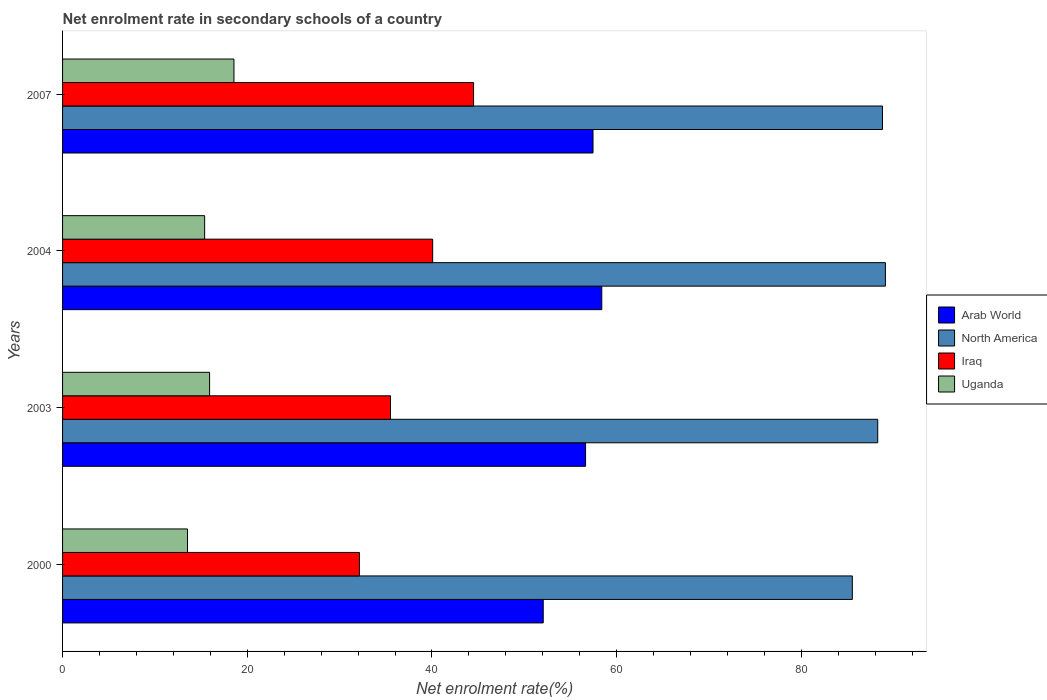Are the number of bars per tick equal to the number of legend labels?
Give a very brief answer. Yes. How many bars are there on the 1st tick from the bottom?
Your response must be concise. 4. In how many cases, is the number of bars for a given year not equal to the number of legend labels?
Ensure brevity in your answer.  0. What is the net enrolment rate in secondary schools in Iraq in 2004?
Give a very brief answer. 40.07. Across all years, what is the maximum net enrolment rate in secondary schools in Iraq?
Provide a short and direct response. 44.5. Across all years, what is the minimum net enrolment rate in secondary schools in Iraq?
Give a very brief answer. 32.14. In which year was the net enrolment rate in secondary schools in Iraq maximum?
Your answer should be compact. 2007. In which year was the net enrolment rate in secondary schools in Iraq minimum?
Make the answer very short. 2000. What is the total net enrolment rate in secondary schools in Arab World in the graph?
Offer a terse response. 224.5. What is the difference between the net enrolment rate in secondary schools in Iraq in 2000 and that in 2007?
Give a very brief answer. -12.36. What is the difference between the net enrolment rate in secondary schools in Arab World in 2000 and the net enrolment rate in secondary schools in North America in 2007?
Give a very brief answer. -36.73. What is the average net enrolment rate in secondary schools in North America per year?
Offer a very short reply. 87.92. In the year 2007, what is the difference between the net enrolment rate in secondary schools in Iraq and net enrolment rate in secondary schools in Uganda?
Make the answer very short. 25.94. In how many years, is the net enrolment rate in secondary schools in Iraq greater than 68 %?
Keep it short and to the point. 0. What is the ratio of the net enrolment rate in secondary schools in North America in 2000 to that in 2004?
Make the answer very short. 0.96. Is the net enrolment rate in secondary schools in Uganda in 2003 less than that in 2007?
Your answer should be compact. Yes. Is the difference between the net enrolment rate in secondary schools in Iraq in 2003 and 2004 greater than the difference between the net enrolment rate in secondary schools in Uganda in 2003 and 2004?
Make the answer very short. No. What is the difference between the highest and the second highest net enrolment rate in secondary schools in Arab World?
Keep it short and to the point. 0.95. What is the difference between the highest and the lowest net enrolment rate in secondary schools in North America?
Your response must be concise. 3.58. In how many years, is the net enrolment rate in secondary schools in North America greater than the average net enrolment rate in secondary schools in North America taken over all years?
Your answer should be compact. 3. Is the sum of the net enrolment rate in secondary schools in Arab World in 2000 and 2007 greater than the maximum net enrolment rate in secondary schools in North America across all years?
Your response must be concise. Yes. Is it the case that in every year, the sum of the net enrolment rate in secondary schools in Arab World and net enrolment rate in secondary schools in North America is greater than the sum of net enrolment rate in secondary schools in Uganda and net enrolment rate in secondary schools in Iraq?
Give a very brief answer. Yes. What does the 2nd bar from the top in 2007 represents?
Offer a very short reply. Iraq. How many bars are there?
Your response must be concise. 16. What is the difference between two consecutive major ticks on the X-axis?
Offer a very short reply. 20. Are the values on the major ticks of X-axis written in scientific E-notation?
Make the answer very short. No. Does the graph contain grids?
Provide a succinct answer. No. Where does the legend appear in the graph?
Offer a terse response. Center right. How many legend labels are there?
Make the answer very short. 4. How are the legend labels stacked?
Your response must be concise. Vertical. What is the title of the graph?
Keep it short and to the point. Net enrolment rate in secondary schools of a country. What is the label or title of the X-axis?
Give a very brief answer. Net enrolment rate(%). What is the label or title of the Y-axis?
Provide a succinct answer. Years. What is the Net enrolment rate(%) in Arab World in 2000?
Offer a terse response. 52.05. What is the Net enrolment rate(%) in North America in 2000?
Ensure brevity in your answer.  85.52. What is the Net enrolment rate(%) of Iraq in 2000?
Your answer should be compact. 32.14. What is the Net enrolment rate(%) in Uganda in 2000?
Provide a short and direct response. 13.53. What is the Net enrolment rate(%) in Arab World in 2003?
Offer a terse response. 56.63. What is the Net enrolment rate(%) in North America in 2003?
Provide a succinct answer. 88.27. What is the Net enrolment rate(%) in Iraq in 2003?
Your response must be concise. 35.51. What is the Net enrolment rate(%) of Uganda in 2003?
Provide a short and direct response. 15.92. What is the Net enrolment rate(%) in Arab World in 2004?
Keep it short and to the point. 58.39. What is the Net enrolment rate(%) in North America in 2004?
Your answer should be very brief. 89.1. What is the Net enrolment rate(%) of Iraq in 2004?
Your response must be concise. 40.07. What is the Net enrolment rate(%) of Uganda in 2004?
Make the answer very short. 15.38. What is the Net enrolment rate(%) in Arab World in 2007?
Provide a succinct answer. 57.44. What is the Net enrolment rate(%) of North America in 2007?
Provide a succinct answer. 88.78. What is the Net enrolment rate(%) in Iraq in 2007?
Give a very brief answer. 44.5. What is the Net enrolment rate(%) of Uganda in 2007?
Your response must be concise. 18.56. Across all years, what is the maximum Net enrolment rate(%) in Arab World?
Offer a very short reply. 58.39. Across all years, what is the maximum Net enrolment rate(%) of North America?
Offer a terse response. 89.1. Across all years, what is the maximum Net enrolment rate(%) in Iraq?
Keep it short and to the point. 44.5. Across all years, what is the maximum Net enrolment rate(%) of Uganda?
Make the answer very short. 18.56. Across all years, what is the minimum Net enrolment rate(%) in Arab World?
Your answer should be compact. 52.05. Across all years, what is the minimum Net enrolment rate(%) in North America?
Provide a short and direct response. 85.52. Across all years, what is the minimum Net enrolment rate(%) of Iraq?
Provide a succinct answer. 32.14. Across all years, what is the minimum Net enrolment rate(%) in Uganda?
Provide a succinct answer. 13.53. What is the total Net enrolment rate(%) of Arab World in the graph?
Your answer should be compact. 224.5. What is the total Net enrolment rate(%) of North America in the graph?
Your response must be concise. 351.67. What is the total Net enrolment rate(%) of Iraq in the graph?
Your response must be concise. 152.23. What is the total Net enrolment rate(%) in Uganda in the graph?
Your answer should be very brief. 63.39. What is the difference between the Net enrolment rate(%) in Arab World in 2000 and that in 2003?
Provide a short and direct response. -4.58. What is the difference between the Net enrolment rate(%) of North America in 2000 and that in 2003?
Offer a very short reply. -2.75. What is the difference between the Net enrolment rate(%) of Iraq in 2000 and that in 2003?
Ensure brevity in your answer.  -3.37. What is the difference between the Net enrolment rate(%) in Uganda in 2000 and that in 2003?
Offer a terse response. -2.39. What is the difference between the Net enrolment rate(%) of Arab World in 2000 and that in 2004?
Make the answer very short. -6.34. What is the difference between the Net enrolment rate(%) in North America in 2000 and that in 2004?
Your answer should be compact. -3.58. What is the difference between the Net enrolment rate(%) in Iraq in 2000 and that in 2004?
Offer a terse response. -7.93. What is the difference between the Net enrolment rate(%) of Uganda in 2000 and that in 2004?
Provide a short and direct response. -1.85. What is the difference between the Net enrolment rate(%) in Arab World in 2000 and that in 2007?
Provide a succinct answer. -5.39. What is the difference between the Net enrolment rate(%) of North America in 2000 and that in 2007?
Offer a terse response. -3.27. What is the difference between the Net enrolment rate(%) of Iraq in 2000 and that in 2007?
Provide a succinct answer. -12.36. What is the difference between the Net enrolment rate(%) of Uganda in 2000 and that in 2007?
Offer a terse response. -5.03. What is the difference between the Net enrolment rate(%) in Arab World in 2003 and that in 2004?
Your answer should be compact. -1.76. What is the difference between the Net enrolment rate(%) of North America in 2003 and that in 2004?
Make the answer very short. -0.83. What is the difference between the Net enrolment rate(%) in Iraq in 2003 and that in 2004?
Make the answer very short. -4.57. What is the difference between the Net enrolment rate(%) of Uganda in 2003 and that in 2004?
Keep it short and to the point. 0.54. What is the difference between the Net enrolment rate(%) of Arab World in 2003 and that in 2007?
Provide a succinct answer. -0.81. What is the difference between the Net enrolment rate(%) of North America in 2003 and that in 2007?
Provide a short and direct response. -0.51. What is the difference between the Net enrolment rate(%) of Iraq in 2003 and that in 2007?
Your answer should be compact. -8.99. What is the difference between the Net enrolment rate(%) in Uganda in 2003 and that in 2007?
Your answer should be very brief. -2.64. What is the difference between the Net enrolment rate(%) in Arab World in 2004 and that in 2007?
Offer a terse response. 0.95. What is the difference between the Net enrolment rate(%) of North America in 2004 and that in 2007?
Ensure brevity in your answer.  0.32. What is the difference between the Net enrolment rate(%) in Iraq in 2004 and that in 2007?
Offer a terse response. -4.43. What is the difference between the Net enrolment rate(%) in Uganda in 2004 and that in 2007?
Offer a very short reply. -3.17. What is the difference between the Net enrolment rate(%) of Arab World in 2000 and the Net enrolment rate(%) of North America in 2003?
Provide a short and direct response. -36.22. What is the difference between the Net enrolment rate(%) of Arab World in 2000 and the Net enrolment rate(%) of Iraq in 2003?
Give a very brief answer. 16.54. What is the difference between the Net enrolment rate(%) in Arab World in 2000 and the Net enrolment rate(%) in Uganda in 2003?
Give a very brief answer. 36.13. What is the difference between the Net enrolment rate(%) of North America in 2000 and the Net enrolment rate(%) of Iraq in 2003?
Provide a short and direct response. 50.01. What is the difference between the Net enrolment rate(%) in North America in 2000 and the Net enrolment rate(%) in Uganda in 2003?
Provide a succinct answer. 69.6. What is the difference between the Net enrolment rate(%) of Iraq in 2000 and the Net enrolment rate(%) of Uganda in 2003?
Offer a terse response. 16.22. What is the difference between the Net enrolment rate(%) in Arab World in 2000 and the Net enrolment rate(%) in North America in 2004?
Give a very brief answer. -37.05. What is the difference between the Net enrolment rate(%) in Arab World in 2000 and the Net enrolment rate(%) in Iraq in 2004?
Give a very brief answer. 11.97. What is the difference between the Net enrolment rate(%) of Arab World in 2000 and the Net enrolment rate(%) of Uganda in 2004?
Your response must be concise. 36.66. What is the difference between the Net enrolment rate(%) of North America in 2000 and the Net enrolment rate(%) of Iraq in 2004?
Provide a succinct answer. 45.44. What is the difference between the Net enrolment rate(%) of North America in 2000 and the Net enrolment rate(%) of Uganda in 2004?
Provide a short and direct response. 70.13. What is the difference between the Net enrolment rate(%) in Iraq in 2000 and the Net enrolment rate(%) in Uganda in 2004?
Ensure brevity in your answer.  16.76. What is the difference between the Net enrolment rate(%) of Arab World in 2000 and the Net enrolment rate(%) of North America in 2007?
Ensure brevity in your answer.  -36.73. What is the difference between the Net enrolment rate(%) of Arab World in 2000 and the Net enrolment rate(%) of Iraq in 2007?
Keep it short and to the point. 7.54. What is the difference between the Net enrolment rate(%) in Arab World in 2000 and the Net enrolment rate(%) in Uganda in 2007?
Offer a terse response. 33.49. What is the difference between the Net enrolment rate(%) in North America in 2000 and the Net enrolment rate(%) in Iraq in 2007?
Offer a terse response. 41.01. What is the difference between the Net enrolment rate(%) in North America in 2000 and the Net enrolment rate(%) in Uganda in 2007?
Give a very brief answer. 66.96. What is the difference between the Net enrolment rate(%) of Iraq in 2000 and the Net enrolment rate(%) of Uganda in 2007?
Provide a succinct answer. 13.58. What is the difference between the Net enrolment rate(%) in Arab World in 2003 and the Net enrolment rate(%) in North America in 2004?
Ensure brevity in your answer.  -32.47. What is the difference between the Net enrolment rate(%) of Arab World in 2003 and the Net enrolment rate(%) of Iraq in 2004?
Give a very brief answer. 16.56. What is the difference between the Net enrolment rate(%) in Arab World in 2003 and the Net enrolment rate(%) in Uganda in 2004?
Keep it short and to the point. 41.25. What is the difference between the Net enrolment rate(%) in North America in 2003 and the Net enrolment rate(%) in Iraq in 2004?
Your response must be concise. 48.19. What is the difference between the Net enrolment rate(%) of North America in 2003 and the Net enrolment rate(%) of Uganda in 2004?
Your response must be concise. 72.88. What is the difference between the Net enrolment rate(%) in Iraq in 2003 and the Net enrolment rate(%) in Uganda in 2004?
Your response must be concise. 20.13. What is the difference between the Net enrolment rate(%) of Arab World in 2003 and the Net enrolment rate(%) of North America in 2007?
Offer a very short reply. -32.15. What is the difference between the Net enrolment rate(%) in Arab World in 2003 and the Net enrolment rate(%) in Iraq in 2007?
Offer a terse response. 12.13. What is the difference between the Net enrolment rate(%) of Arab World in 2003 and the Net enrolment rate(%) of Uganda in 2007?
Your answer should be compact. 38.07. What is the difference between the Net enrolment rate(%) of North America in 2003 and the Net enrolment rate(%) of Iraq in 2007?
Give a very brief answer. 43.76. What is the difference between the Net enrolment rate(%) in North America in 2003 and the Net enrolment rate(%) in Uganda in 2007?
Give a very brief answer. 69.71. What is the difference between the Net enrolment rate(%) in Iraq in 2003 and the Net enrolment rate(%) in Uganda in 2007?
Your answer should be very brief. 16.95. What is the difference between the Net enrolment rate(%) in Arab World in 2004 and the Net enrolment rate(%) in North America in 2007?
Offer a very short reply. -30.39. What is the difference between the Net enrolment rate(%) of Arab World in 2004 and the Net enrolment rate(%) of Iraq in 2007?
Make the answer very short. 13.88. What is the difference between the Net enrolment rate(%) of Arab World in 2004 and the Net enrolment rate(%) of Uganda in 2007?
Provide a short and direct response. 39.83. What is the difference between the Net enrolment rate(%) of North America in 2004 and the Net enrolment rate(%) of Iraq in 2007?
Keep it short and to the point. 44.6. What is the difference between the Net enrolment rate(%) in North America in 2004 and the Net enrolment rate(%) in Uganda in 2007?
Give a very brief answer. 70.54. What is the difference between the Net enrolment rate(%) of Iraq in 2004 and the Net enrolment rate(%) of Uganda in 2007?
Your response must be concise. 21.52. What is the average Net enrolment rate(%) of Arab World per year?
Offer a terse response. 56.13. What is the average Net enrolment rate(%) of North America per year?
Offer a very short reply. 87.92. What is the average Net enrolment rate(%) in Iraq per year?
Your response must be concise. 38.06. What is the average Net enrolment rate(%) in Uganda per year?
Make the answer very short. 15.85. In the year 2000, what is the difference between the Net enrolment rate(%) in Arab World and Net enrolment rate(%) in North America?
Your answer should be very brief. -33.47. In the year 2000, what is the difference between the Net enrolment rate(%) in Arab World and Net enrolment rate(%) in Iraq?
Your answer should be compact. 19.91. In the year 2000, what is the difference between the Net enrolment rate(%) of Arab World and Net enrolment rate(%) of Uganda?
Offer a very short reply. 38.52. In the year 2000, what is the difference between the Net enrolment rate(%) of North America and Net enrolment rate(%) of Iraq?
Your answer should be compact. 53.37. In the year 2000, what is the difference between the Net enrolment rate(%) of North America and Net enrolment rate(%) of Uganda?
Provide a short and direct response. 71.99. In the year 2000, what is the difference between the Net enrolment rate(%) of Iraq and Net enrolment rate(%) of Uganda?
Provide a succinct answer. 18.61. In the year 2003, what is the difference between the Net enrolment rate(%) of Arab World and Net enrolment rate(%) of North America?
Keep it short and to the point. -31.64. In the year 2003, what is the difference between the Net enrolment rate(%) of Arab World and Net enrolment rate(%) of Iraq?
Make the answer very short. 21.12. In the year 2003, what is the difference between the Net enrolment rate(%) of Arab World and Net enrolment rate(%) of Uganda?
Keep it short and to the point. 40.71. In the year 2003, what is the difference between the Net enrolment rate(%) in North America and Net enrolment rate(%) in Iraq?
Provide a short and direct response. 52.76. In the year 2003, what is the difference between the Net enrolment rate(%) of North America and Net enrolment rate(%) of Uganda?
Keep it short and to the point. 72.35. In the year 2003, what is the difference between the Net enrolment rate(%) in Iraq and Net enrolment rate(%) in Uganda?
Ensure brevity in your answer.  19.59. In the year 2004, what is the difference between the Net enrolment rate(%) in Arab World and Net enrolment rate(%) in North America?
Give a very brief answer. -30.71. In the year 2004, what is the difference between the Net enrolment rate(%) in Arab World and Net enrolment rate(%) in Iraq?
Offer a terse response. 18.31. In the year 2004, what is the difference between the Net enrolment rate(%) of Arab World and Net enrolment rate(%) of Uganda?
Make the answer very short. 43. In the year 2004, what is the difference between the Net enrolment rate(%) of North America and Net enrolment rate(%) of Iraq?
Your response must be concise. 49.02. In the year 2004, what is the difference between the Net enrolment rate(%) in North America and Net enrolment rate(%) in Uganda?
Offer a very short reply. 73.72. In the year 2004, what is the difference between the Net enrolment rate(%) of Iraq and Net enrolment rate(%) of Uganda?
Offer a very short reply. 24.69. In the year 2007, what is the difference between the Net enrolment rate(%) of Arab World and Net enrolment rate(%) of North America?
Your answer should be very brief. -31.34. In the year 2007, what is the difference between the Net enrolment rate(%) of Arab World and Net enrolment rate(%) of Iraq?
Keep it short and to the point. 12.93. In the year 2007, what is the difference between the Net enrolment rate(%) in Arab World and Net enrolment rate(%) in Uganda?
Ensure brevity in your answer.  38.88. In the year 2007, what is the difference between the Net enrolment rate(%) in North America and Net enrolment rate(%) in Iraq?
Keep it short and to the point. 44.28. In the year 2007, what is the difference between the Net enrolment rate(%) in North America and Net enrolment rate(%) in Uganda?
Provide a succinct answer. 70.22. In the year 2007, what is the difference between the Net enrolment rate(%) of Iraq and Net enrolment rate(%) of Uganda?
Offer a very short reply. 25.94. What is the ratio of the Net enrolment rate(%) of Arab World in 2000 to that in 2003?
Your response must be concise. 0.92. What is the ratio of the Net enrolment rate(%) in North America in 2000 to that in 2003?
Make the answer very short. 0.97. What is the ratio of the Net enrolment rate(%) in Iraq in 2000 to that in 2003?
Keep it short and to the point. 0.91. What is the ratio of the Net enrolment rate(%) of Uganda in 2000 to that in 2003?
Provide a succinct answer. 0.85. What is the ratio of the Net enrolment rate(%) of Arab World in 2000 to that in 2004?
Offer a terse response. 0.89. What is the ratio of the Net enrolment rate(%) in North America in 2000 to that in 2004?
Offer a very short reply. 0.96. What is the ratio of the Net enrolment rate(%) in Iraq in 2000 to that in 2004?
Provide a short and direct response. 0.8. What is the ratio of the Net enrolment rate(%) in Uganda in 2000 to that in 2004?
Give a very brief answer. 0.88. What is the ratio of the Net enrolment rate(%) in Arab World in 2000 to that in 2007?
Give a very brief answer. 0.91. What is the ratio of the Net enrolment rate(%) in North America in 2000 to that in 2007?
Your response must be concise. 0.96. What is the ratio of the Net enrolment rate(%) in Iraq in 2000 to that in 2007?
Provide a succinct answer. 0.72. What is the ratio of the Net enrolment rate(%) in Uganda in 2000 to that in 2007?
Make the answer very short. 0.73. What is the ratio of the Net enrolment rate(%) of Arab World in 2003 to that in 2004?
Your answer should be compact. 0.97. What is the ratio of the Net enrolment rate(%) of North America in 2003 to that in 2004?
Your answer should be compact. 0.99. What is the ratio of the Net enrolment rate(%) of Iraq in 2003 to that in 2004?
Provide a succinct answer. 0.89. What is the ratio of the Net enrolment rate(%) of Uganda in 2003 to that in 2004?
Give a very brief answer. 1.03. What is the ratio of the Net enrolment rate(%) of Arab World in 2003 to that in 2007?
Ensure brevity in your answer.  0.99. What is the ratio of the Net enrolment rate(%) in North America in 2003 to that in 2007?
Your answer should be compact. 0.99. What is the ratio of the Net enrolment rate(%) in Iraq in 2003 to that in 2007?
Make the answer very short. 0.8. What is the ratio of the Net enrolment rate(%) in Uganda in 2003 to that in 2007?
Your answer should be compact. 0.86. What is the ratio of the Net enrolment rate(%) in Arab World in 2004 to that in 2007?
Your answer should be compact. 1.02. What is the ratio of the Net enrolment rate(%) in North America in 2004 to that in 2007?
Provide a succinct answer. 1. What is the ratio of the Net enrolment rate(%) of Iraq in 2004 to that in 2007?
Make the answer very short. 0.9. What is the ratio of the Net enrolment rate(%) of Uganda in 2004 to that in 2007?
Your answer should be very brief. 0.83. What is the difference between the highest and the second highest Net enrolment rate(%) in Arab World?
Ensure brevity in your answer.  0.95. What is the difference between the highest and the second highest Net enrolment rate(%) in North America?
Provide a succinct answer. 0.32. What is the difference between the highest and the second highest Net enrolment rate(%) in Iraq?
Offer a very short reply. 4.43. What is the difference between the highest and the second highest Net enrolment rate(%) in Uganda?
Offer a very short reply. 2.64. What is the difference between the highest and the lowest Net enrolment rate(%) of Arab World?
Provide a succinct answer. 6.34. What is the difference between the highest and the lowest Net enrolment rate(%) of North America?
Offer a very short reply. 3.58. What is the difference between the highest and the lowest Net enrolment rate(%) of Iraq?
Provide a short and direct response. 12.36. What is the difference between the highest and the lowest Net enrolment rate(%) in Uganda?
Provide a short and direct response. 5.03. 